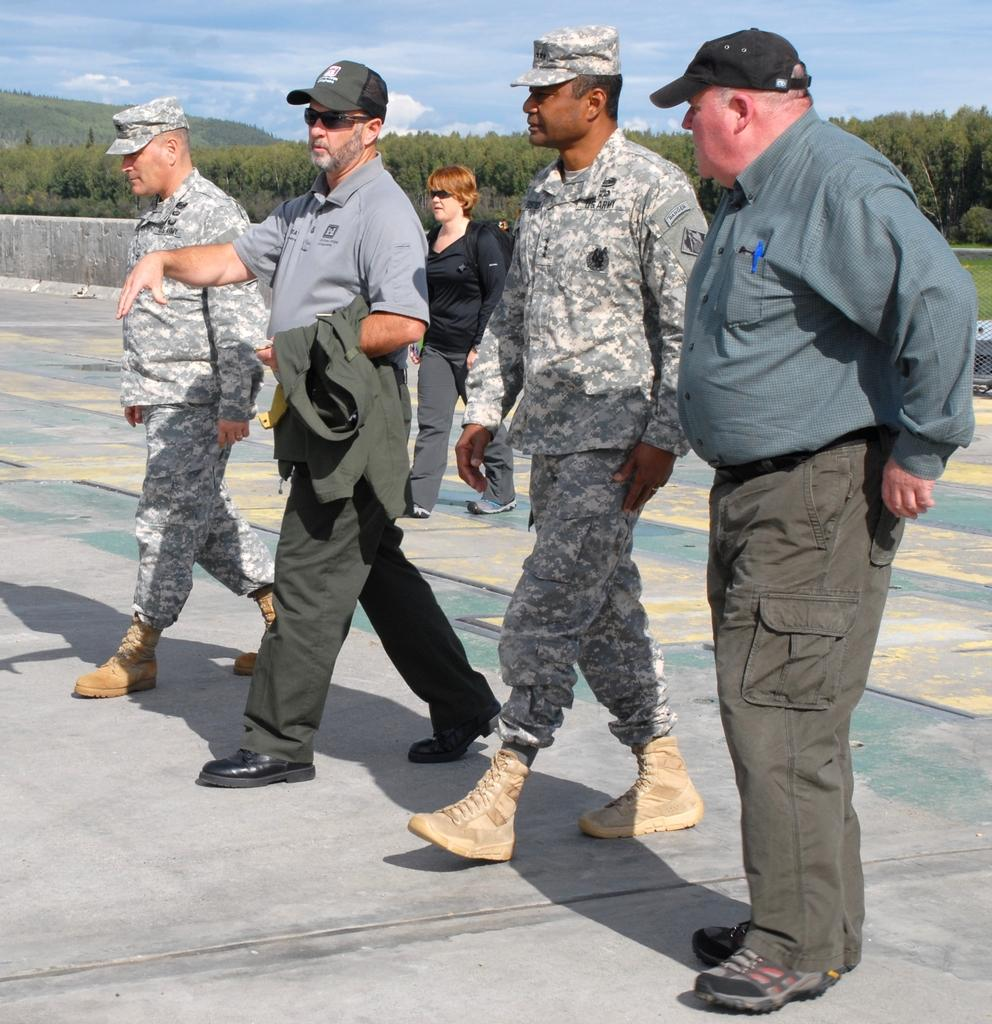What is the main subject of the image? The main subject of the image is a group of people. Can you describe the attire of some of the people in the image? Some of the people in the image are wearing uniforms and caps. What can be seen in the background of the image? There are trees and the sky visible in the background of the image. What type of scarecrow is standing among the trees in the image? There is no scarecrow present in the image; it features a group of people and trees in the background. How does the crib fit into the image? There is no crib present in the image; it features a group of people and trees in the background. 